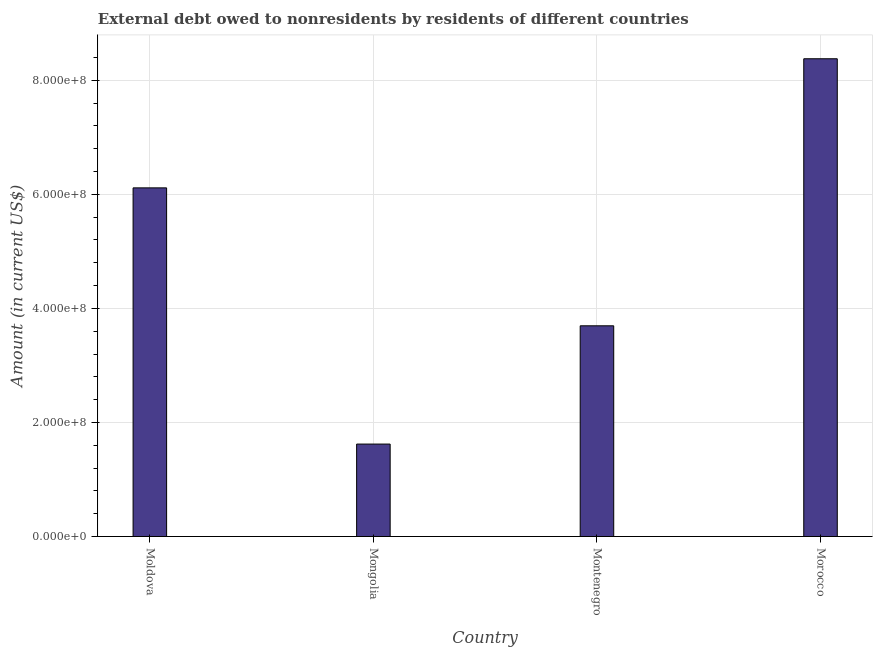Does the graph contain any zero values?
Your response must be concise. No. Does the graph contain grids?
Offer a terse response. Yes. What is the title of the graph?
Keep it short and to the point. External debt owed to nonresidents by residents of different countries. What is the label or title of the X-axis?
Provide a succinct answer. Country. What is the label or title of the Y-axis?
Your response must be concise. Amount (in current US$). What is the debt in Moldova?
Your response must be concise. 6.11e+08. Across all countries, what is the maximum debt?
Offer a very short reply. 8.38e+08. Across all countries, what is the minimum debt?
Offer a very short reply. 1.62e+08. In which country was the debt maximum?
Provide a short and direct response. Morocco. In which country was the debt minimum?
Offer a terse response. Mongolia. What is the sum of the debt?
Your answer should be compact. 1.98e+09. What is the difference between the debt in Mongolia and Morocco?
Give a very brief answer. -6.76e+08. What is the average debt per country?
Offer a very short reply. 4.95e+08. What is the median debt?
Your answer should be compact. 4.90e+08. What is the ratio of the debt in Montenegro to that in Morocco?
Provide a succinct answer. 0.44. Is the debt in Moldova less than that in Morocco?
Offer a very short reply. Yes. What is the difference between the highest and the second highest debt?
Make the answer very short. 2.26e+08. Is the sum of the debt in Mongolia and Morocco greater than the maximum debt across all countries?
Provide a succinct answer. Yes. What is the difference between the highest and the lowest debt?
Ensure brevity in your answer.  6.76e+08. How many bars are there?
Your answer should be compact. 4. Are all the bars in the graph horizontal?
Give a very brief answer. No. How many countries are there in the graph?
Give a very brief answer. 4. Are the values on the major ticks of Y-axis written in scientific E-notation?
Make the answer very short. Yes. What is the Amount (in current US$) in Moldova?
Provide a short and direct response. 6.11e+08. What is the Amount (in current US$) in Mongolia?
Offer a terse response. 1.62e+08. What is the Amount (in current US$) in Montenegro?
Provide a short and direct response. 3.69e+08. What is the Amount (in current US$) in Morocco?
Give a very brief answer. 8.38e+08. What is the difference between the Amount (in current US$) in Moldova and Mongolia?
Offer a terse response. 4.49e+08. What is the difference between the Amount (in current US$) in Moldova and Montenegro?
Your response must be concise. 2.42e+08. What is the difference between the Amount (in current US$) in Moldova and Morocco?
Ensure brevity in your answer.  -2.26e+08. What is the difference between the Amount (in current US$) in Mongolia and Montenegro?
Your answer should be compact. -2.07e+08. What is the difference between the Amount (in current US$) in Mongolia and Morocco?
Offer a very short reply. -6.76e+08. What is the difference between the Amount (in current US$) in Montenegro and Morocco?
Your answer should be compact. -4.68e+08. What is the ratio of the Amount (in current US$) in Moldova to that in Mongolia?
Your answer should be very brief. 3.77. What is the ratio of the Amount (in current US$) in Moldova to that in Montenegro?
Keep it short and to the point. 1.66. What is the ratio of the Amount (in current US$) in Moldova to that in Morocco?
Your answer should be compact. 0.73. What is the ratio of the Amount (in current US$) in Mongolia to that in Montenegro?
Ensure brevity in your answer.  0.44. What is the ratio of the Amount (in current US$) in Mongolia to that in Morocco?
Offer a very short reply. 0.19. What is the ratio of the Amount (in current US$) in Montenegro to that in Morocco?
Offer a terse response. 0.44. 